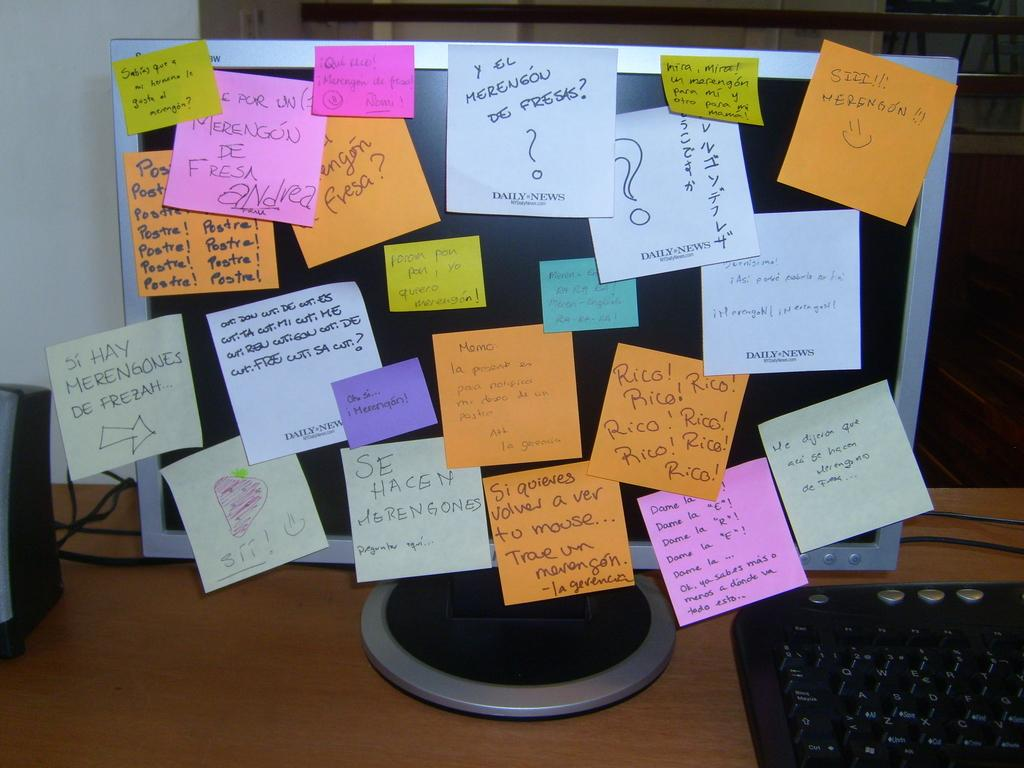<image>
Summarize the visual content of the image. A monitor is plastered with post-it notes with an orange note in the corner that says SIIII!!! and a smiley face. 